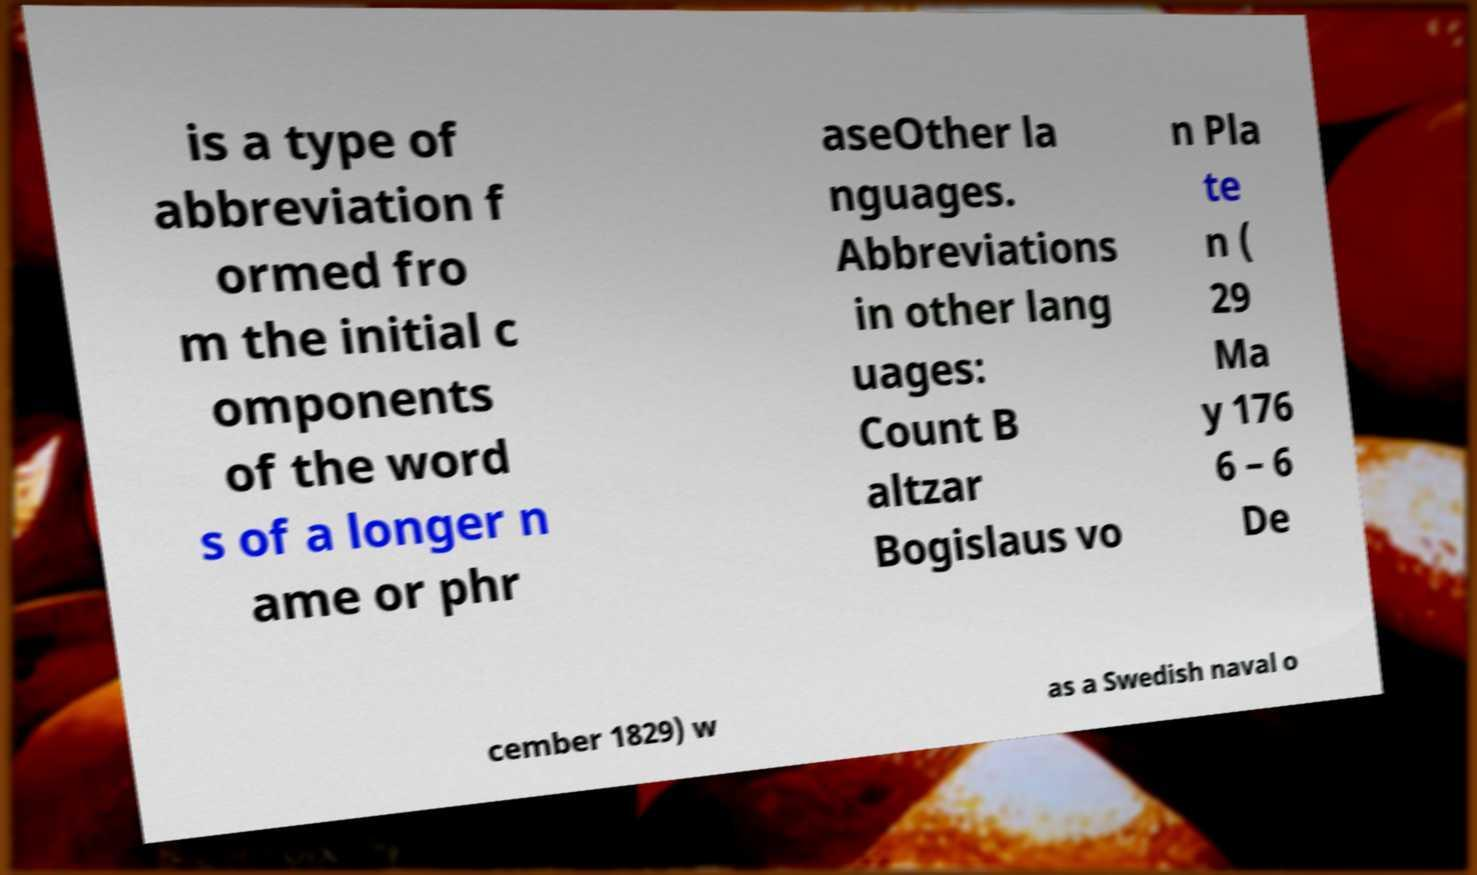Can you read and provide the text displayed in the image?This photo seems to have some interesting text. Can you extract and type it out for me? is a type of abbreviation f ormed fro m the initial c omponents of the word s of a longer n ame or phr aseOther la nguages. Abbreviations in other lang uages: Count B altzar Bogislaus vo n Pla te n ( 29 Ma y 176 6 – 6 De cember 1829) w as a Swedish naval o 